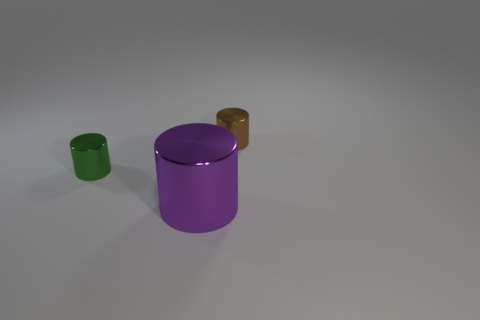Can you describe the objects that are present in this image? In the image, there are three cylindrical objects placed on a flat surface. The largest cylinder is purple with a reflective surface, and there's a smaller green cylinder located to its left along with a tiny brown cylinder to its right. All objects seem to have a sleek, metallic finish. 